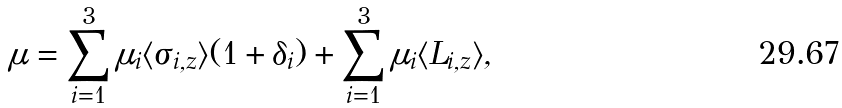Convert formula to latex. <formula><loc_0><loc_0><loc_500><loc_500>\mu = \sum _ { i = 1 } ^ { 3 } \mu _ { i } \langle \sigma _ { i , z } \rangle ( 1 + \delta _ { i } ) + \sum _ { i = 1 } ^ { 3 } \mu _ { i } \langle L _ { i , z } \rangle ,</formula> 